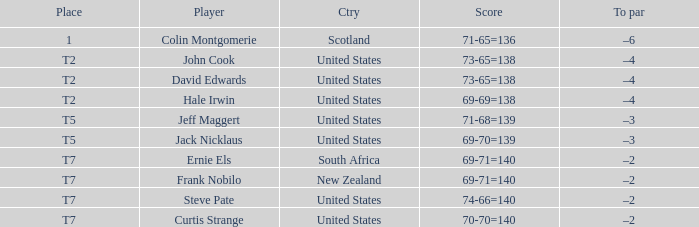What is the name of the golfer that has the score of 73-65=138? John Cook, David Edwards. 